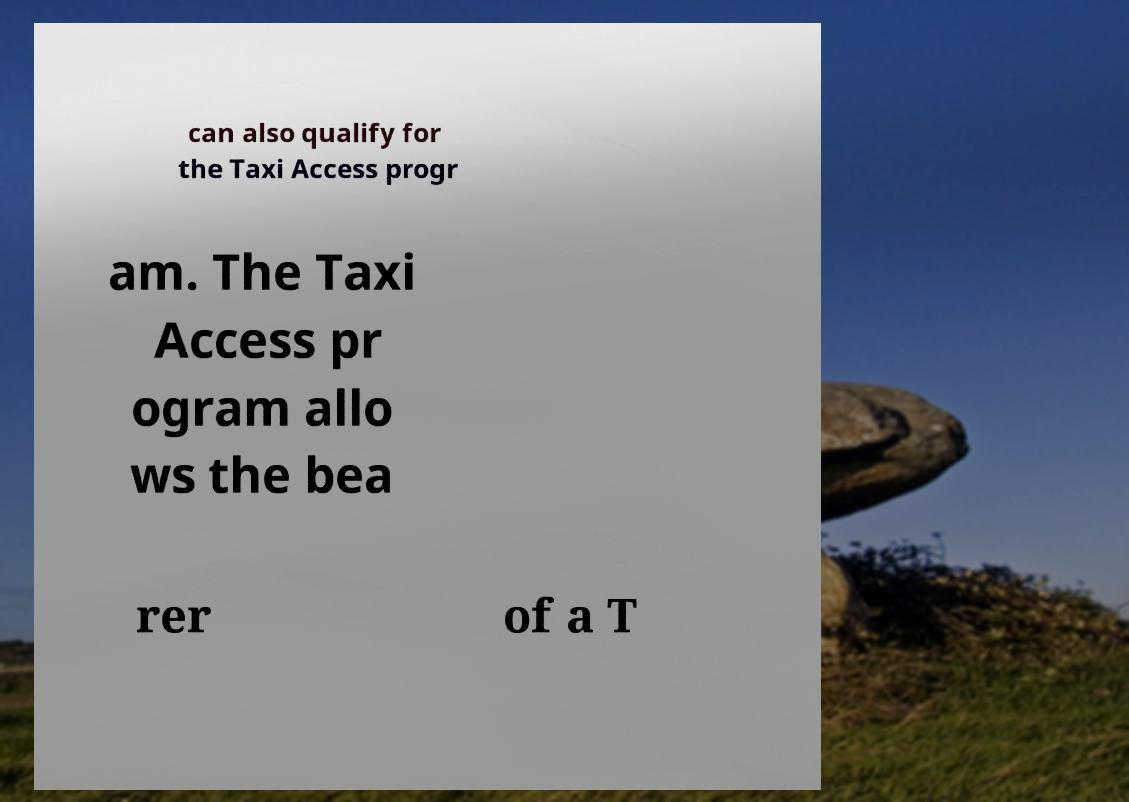There's text embedded in this image that I need extracted. Can you transcribe it verbatim? can also qualify for the Taxi Access progr am. The Taxi Access pr ogram allo ws the bea rer of a T 